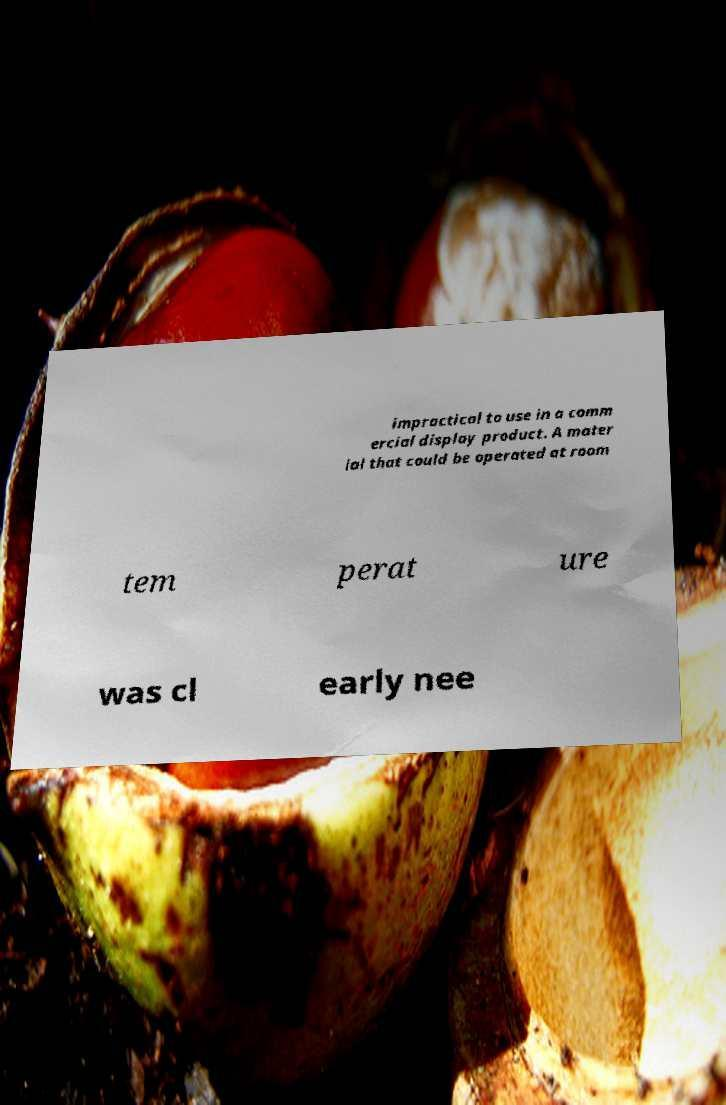Can you read and provide the text displayed in the image?This photo seems to have some interesting text. Can you extract and type it out for me? impractical to use in a comm ercial display product. A mater ial that could be operated at room tem perat ure was cl early nee 